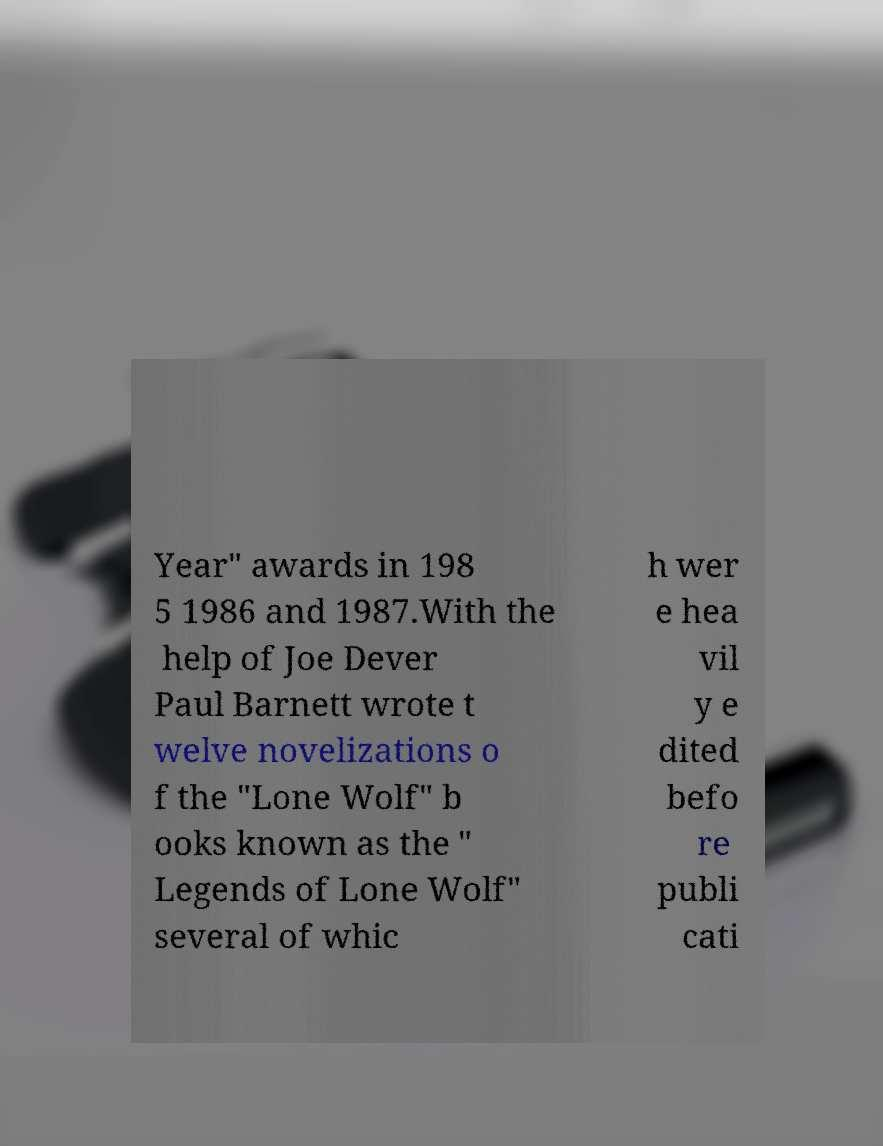Please identify and transcribe the text found in this image. Year" awards in 198 5 1986 and 1987.With the help of Joe Dever Paul Barnett wrote t welve novelizations o f the "Lone Wolf" b ooks known as the " Legends of Lone Wolf" several of whic h wer e hea vil y e dited befo re publi cati 